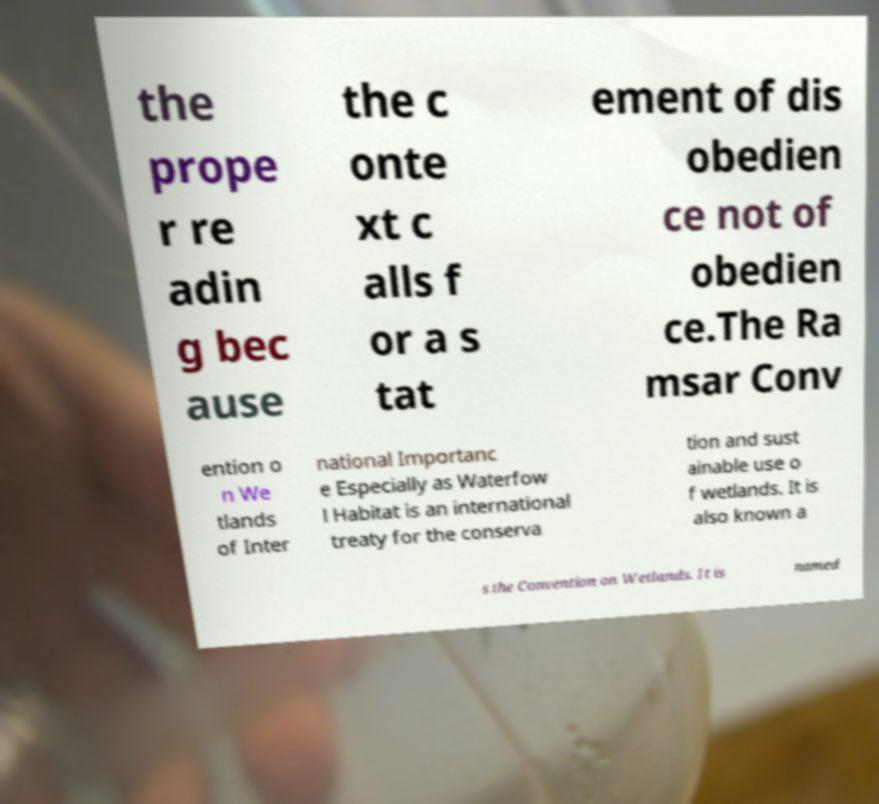Please read and relay the text visible in this image. What does it say? the prope r re adin g bec ause the c onte xt c alls f or a s tat ement of dis obedien ce not of obedien ce.The Ra msar Conv ention o n We tlands of Inter national Importanc e Especially as Waterfow l Habitat is an international treaty for the conserva tion and sust ainable use o f wetlands. It is also known a s the Convention on Wetlands. It is named 